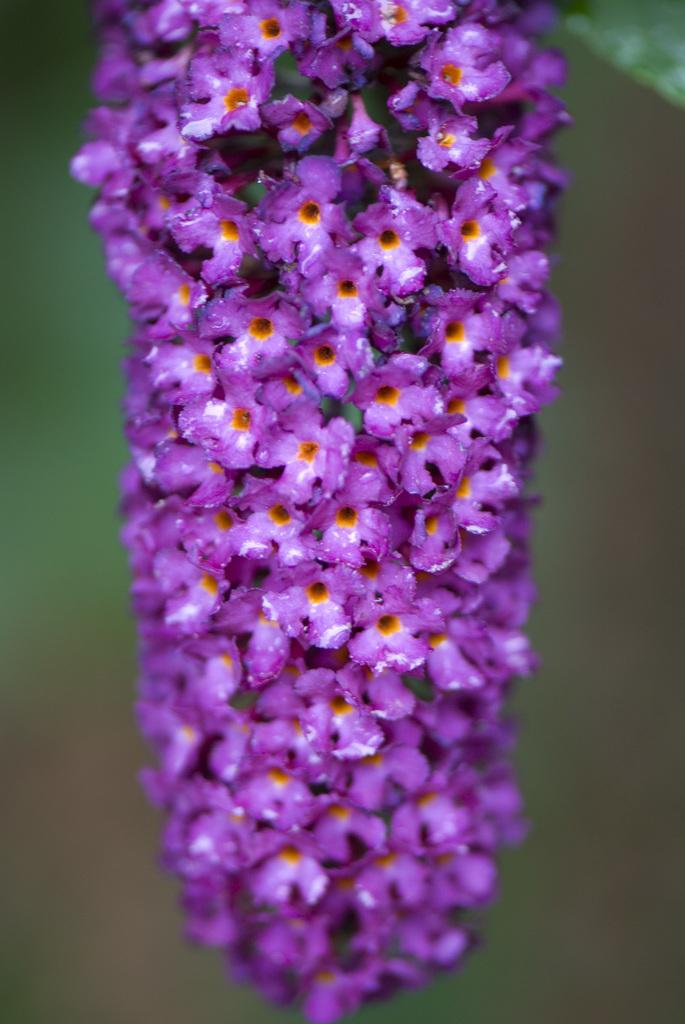What type of flowers can be seen in the front of the image? There are purple color flowers in the front of the image. Can you describe the background of the image? The background of the image is blurred. What type of beetle can be seen crawling on the flowers in the image? There is no beetle present in the image; it only features purple color flowers. 